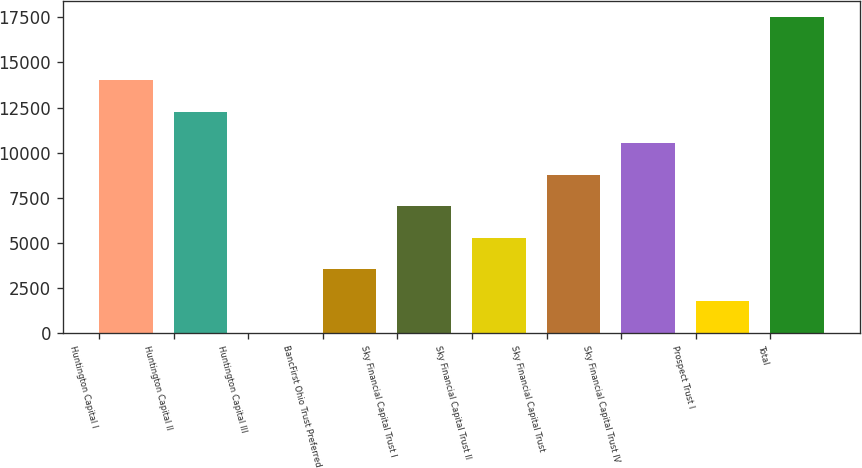Convert chart to OTSL. <chart><loc_0><loc_0><loc_500><loc_500><bar_chart><fcel>Huntington Capital I<fcel>Huntington Capital II<fcel>Huntington Capital III<fcel>BancFirst Ohio Trust Preferred<fcel>Sky Financial Capital Trust I<fcel>Sky Financial Capital Trust II<fcel>Sky Financial Capital Trust<fcel>Sky Financial Capital Trust IV<fcel>Prospect Trust I<fcel>Total<nl><fcel>14017.2<fcel>12266.3<fcel>10<fcel>3511.8<fcel>7013.6<fcel>5262.7<fcel>8764.5<fcel>10515.4<fcel>1760.9<fcel>17519<nl></chart> 